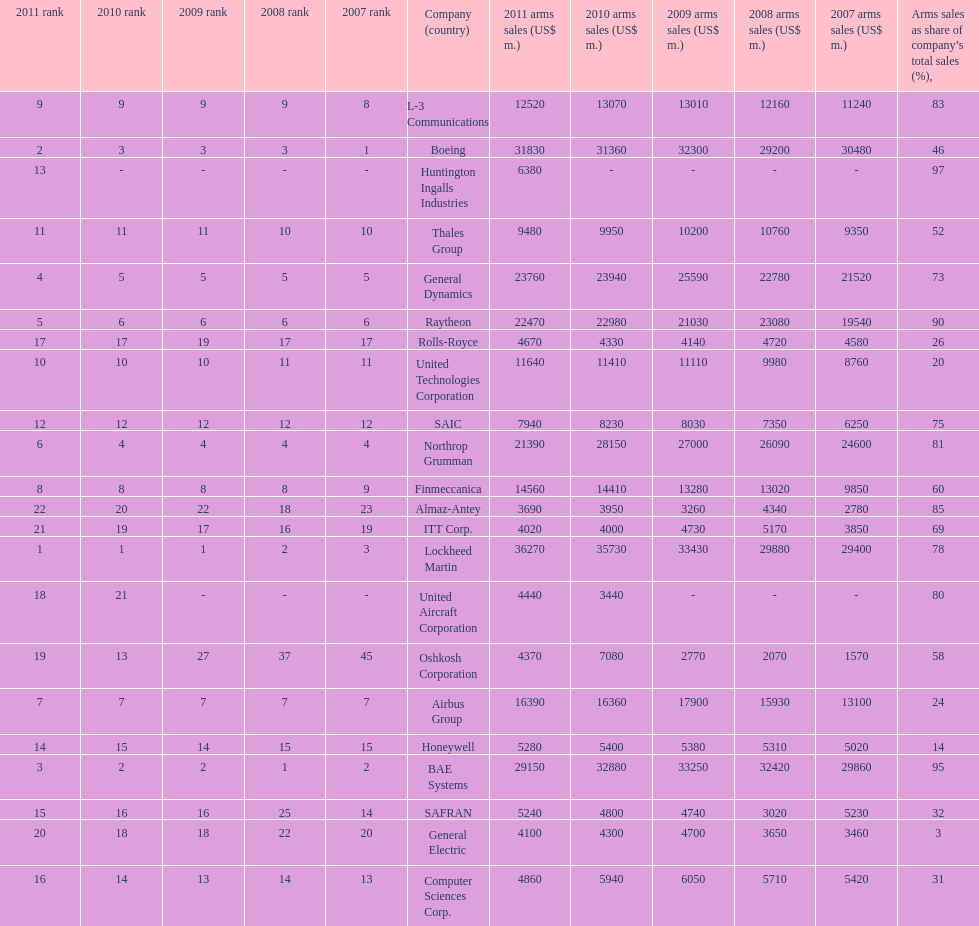Which is the only company to have under 10% arms sales as share of company's total sales? General Electric. 